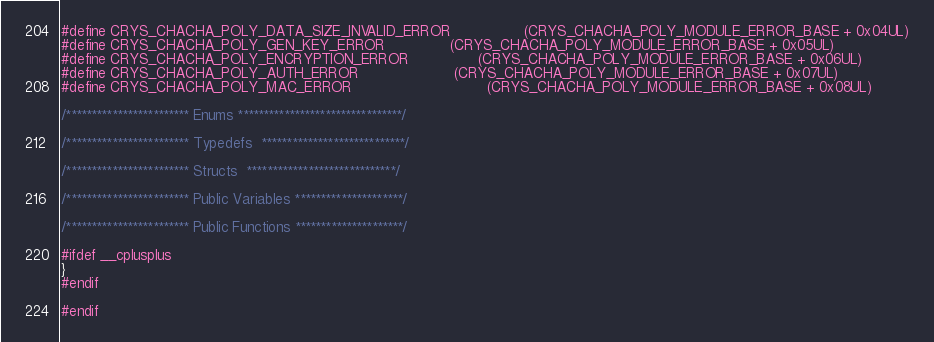Convert code to text. <code><loc_0><loc_0><loc_500><loc_500><_C_>#define CRYS_CHACHA_POLY_DATA_SIZE_INVALID_ERROR             	(CRYS_CHACHA_POLY_MODULE_ERROR_BASE + 0x04UL)
#define CRYS_CHACHA_POLY_GEN_KEY_ERROR          		(CRYS_CHACHA_POLY_MODULE_ERROR_BASE + 0x05UL)
#define CRYS_CHACHA_POLY_ENCRYPTION_ERROR         		(CRYS_CHACHA_POLY_MODULE_ERROR_BASE + 0x06UL)
#define CRYS_CHACHA_POLY_AUTH_ERROR          			(CRYS_CHACHA_POLY_MODULE_ERROR_BASE + 0x07UL)
#define CRYS_CHACHA_POLY_MAC_ERROR                             	(CRYS_CHACHA_POLY_MODULE_ERROR_BASE + 0x08UL)

/************************ Enums ********************************/

/************************ Typedefs  ****************************/

/************************ Structs  *****************************/

/************************ Public Variables *********************/

/************************ Public Functions *********************/

#ifdef __cplusplus
}
#endif

#endif


</code> 